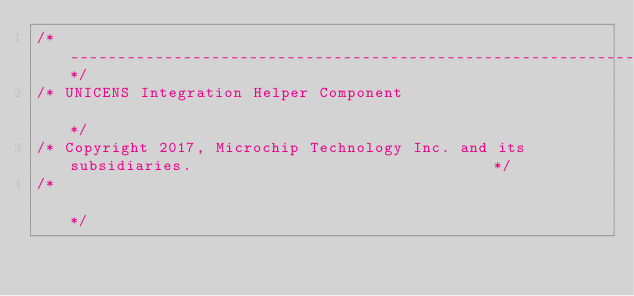<code> <loc_0><loc_0><loc_500><loc_500><_C_>/*------------------------------------------------------------------------------------------------*/
/* UNICENS Integration Helper Component                                                           */
/* Copyright 2017, Microchip Technology Inc. and its subsidiaries.                                */
/*                                                                                                */</code> 